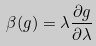<formula> <loc_0><loc_0><loc_500><loc_500>\beta ( g ) = \lambda \frac { \partial g } { \partial \lambda }</formula> 